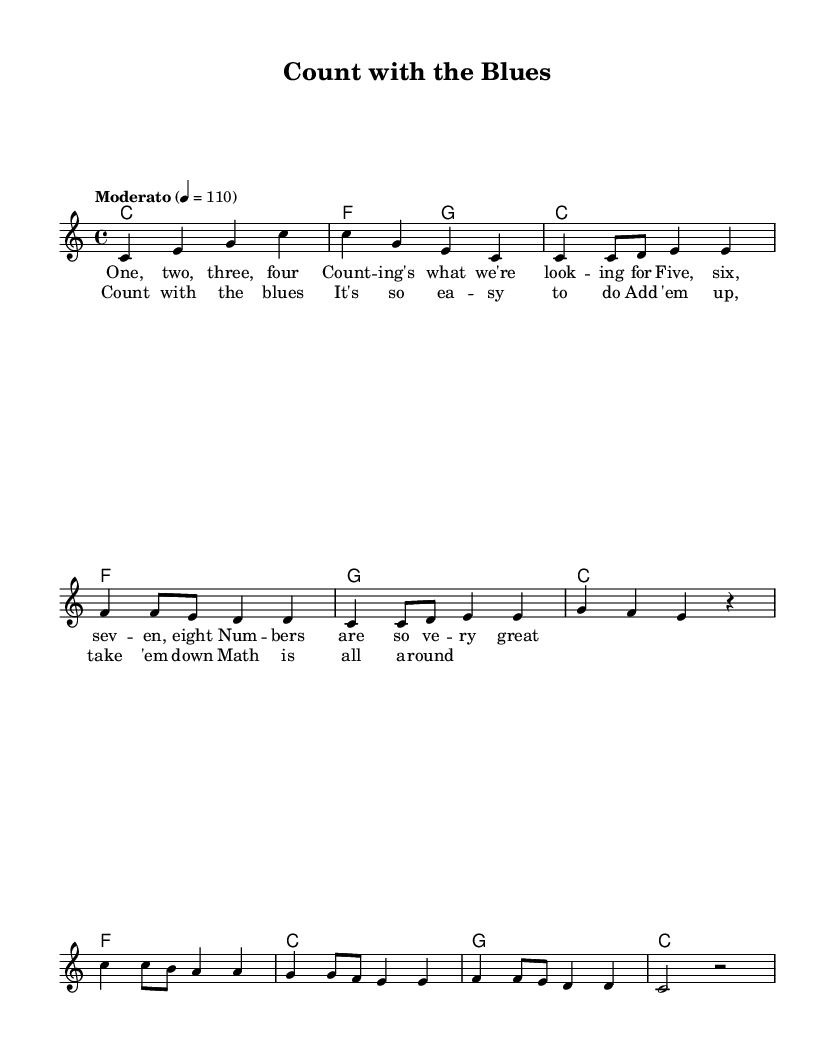What is the key signature of this music? The key signature is indicated as C major, which features no sharps or flats in its scale.
Answer: C major What is the time signature of this music? The time signature, shown at the beginning of the score, is 4/4, meaning there are four beats in each measure.
Answer: 4/4 What is the tempo of the piece? The tempo marking states "Moderato" with a metronome marking of 110, indicating a moderate speed for the piece.
Answer: Moderato 4 = 110 How many measures are there in the verse? The verse section contains eight measures, as indicated by counting the measures in the melody part.
Answer: Eight Which note appears most frequently in the chorus? In the chorus, the note "e" appears most frequently as it is repeated multiple times.
Answer: E What kind of chords are predominantly used in this music? The chords used are primarily triads, which are the basic three-note chords typical in Rhythm and Blues songs, forming a simple harmonic structure.
Answer: Triads What is the primary theme expressed in the lyrics? The lyrics focus on counting and appreciation of numbers, highlighting their importance in a playful manner suitable for children.
Answer: Counting 